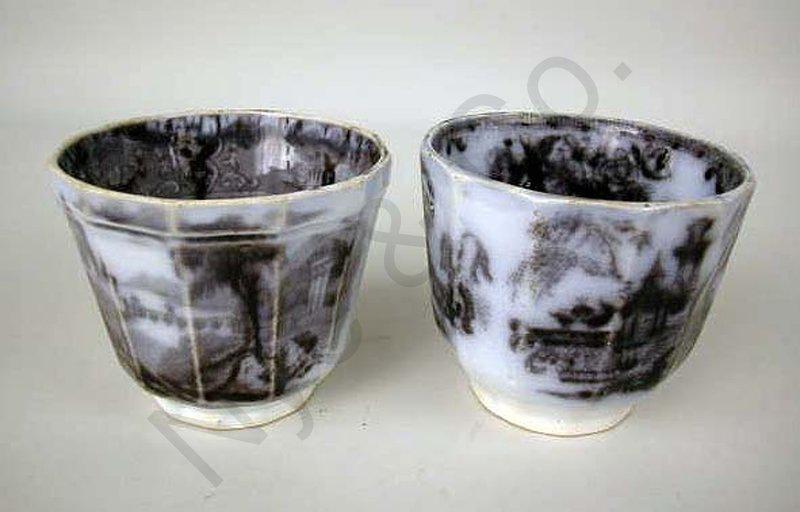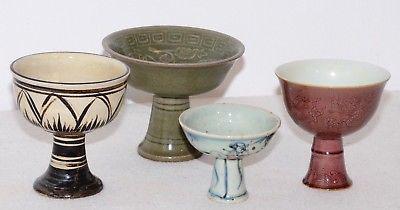The first image is the image on the left, the second image is the image on the right. Examine the images to the left and right. Is the description "There are exactly 6 cups, and no other objects." accurate? Answer yes or no. Yes. The first image is the image on the left, the second image is the image on the right. Examine the images to the left and right. Is the description "The image on the left shows three greenish mugs on a wooden table." accurate? Answer yes or no. No. 